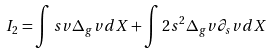<formula> <loc_0><loc_0><loc_500><loc_500>I _ { 2 } = \int s v \Delta _ { g } v d X + \int 2 s ^ { 2 } \Delta _ { g } v \partial _ { s } v d X</formula> 